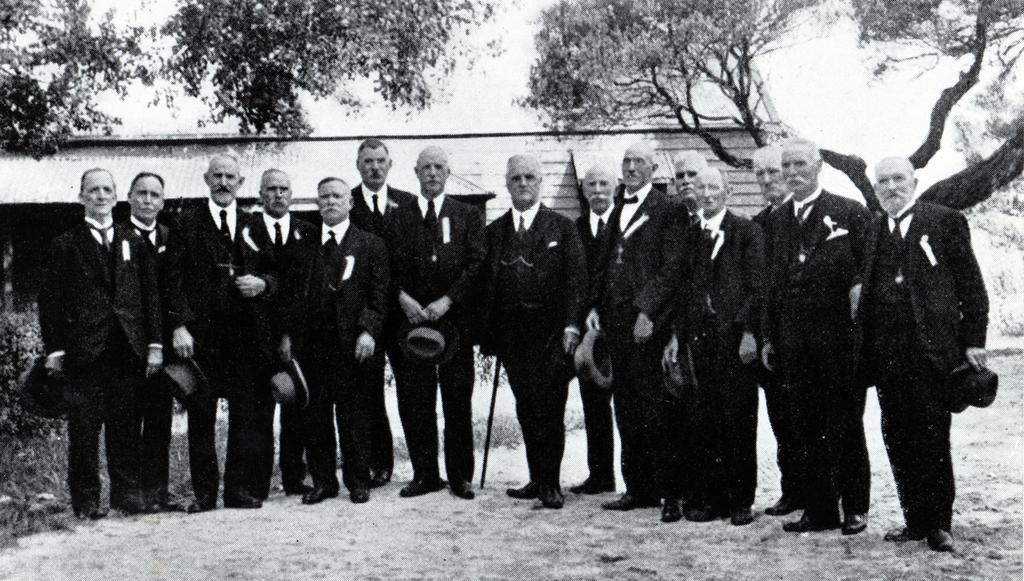Can you describe this image briefly? In this image I can see group of people standing. Background I can see a house, trees and sky, and the image is in black and white. 